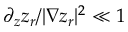Convert formula to latex. <formula><loc_0><loc_0><loc_500><loc_500>\partial _ { z } z _ { r } / | \nabla z _ { r } | ^ { 2 } \ll 1</formula> 